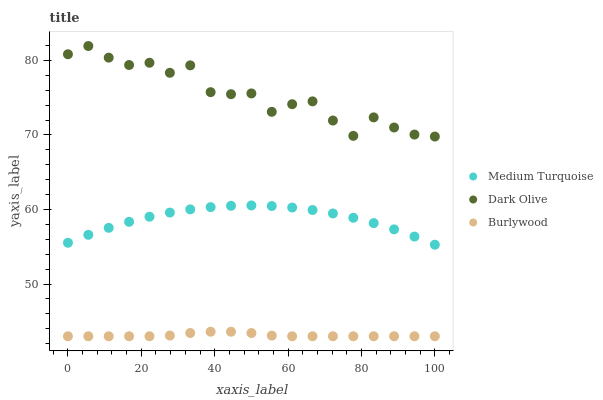Does Burlywood have the minimum area under the curve?
Answer yes or no. Yes. Does Dark Olive have the maximum area under the curve?
Answer yes or no. Yes. Does Medium Turquoise have the minimum area under the curve?
Answer yes or no. No. Does Medium Turquoise have the maximum area under the curve?
Answer yes or no. No. Is Burlywood the smoothest?
Answer yes or no. Yes. Is Dark Olive the roughest?
Answer yes or no. Yes. Is Medium Turquoise the smoothest?
Answer yes or no. No. Is Medium Turquoise the roughest?
Answer yes or no. No. Does Burlywood have the lowest value?
Answer yes or no. Yes. Does Medium Turquoise have the lowest value?
Answer yes or no. No. Does Dark Olive have the highest value?
Answer yes or no. Yes. Does Medium Turquoise have the highest value?
Answer yes or no. No. Is Burlywood less than Dark Olive?
Answer yes or no. Yes. Is Medium Turquoise greater than Burlywood?
Answer yes or no. Yes. Does Burlywood intersect Dark Olive?
Answer yes or no. No. 